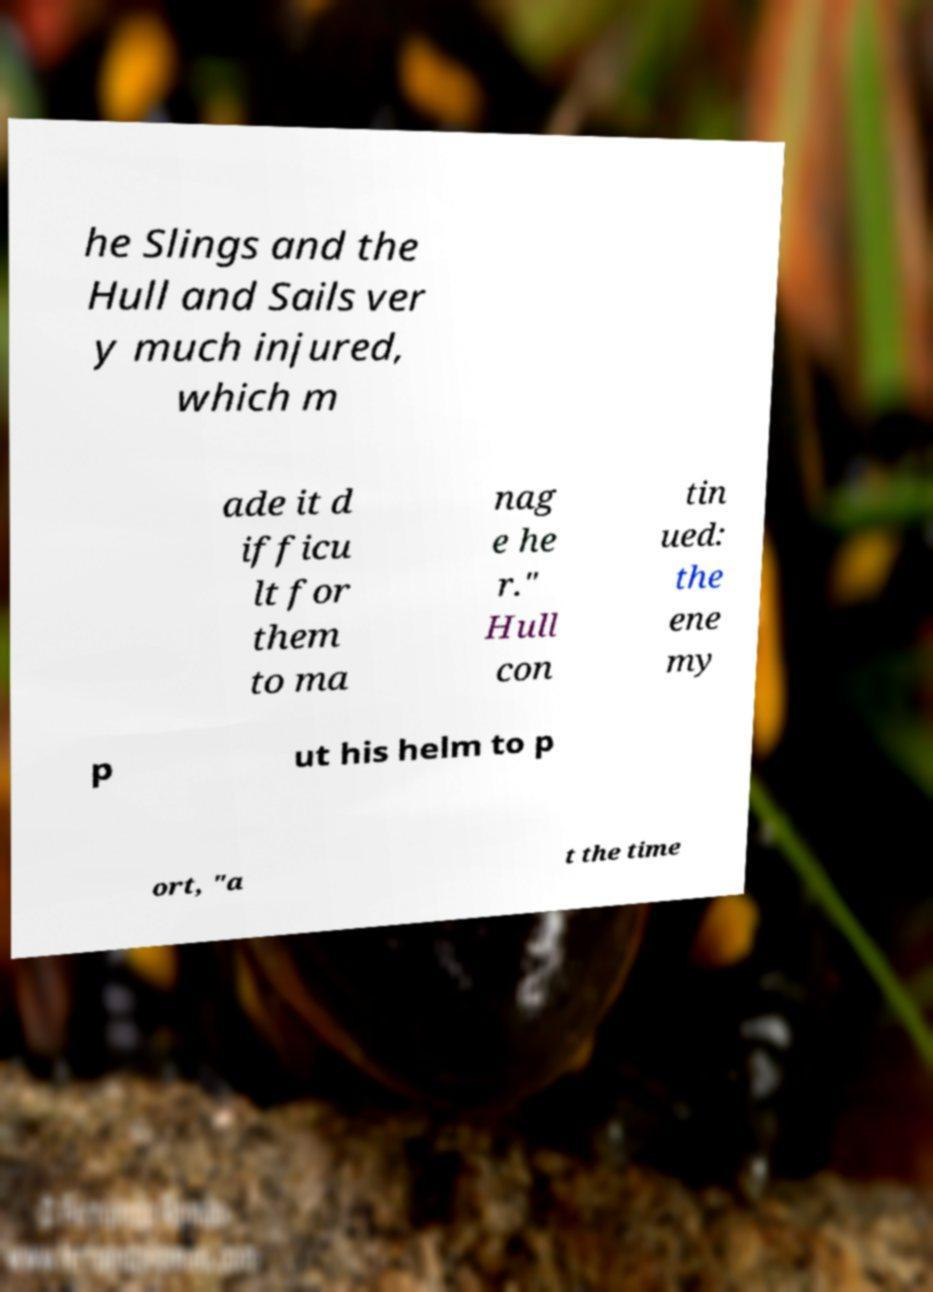Can you read and provide the text displayed in the image?This photo seems to have some interesting text. Can you extract and type it out for me? he Slings and the Hull and Sails ver y much injured, which m ade it d ifficu lt for them to ma nag e he r." Hull con tin ued: the ene my p ut his helm to p ort, "a t the time 